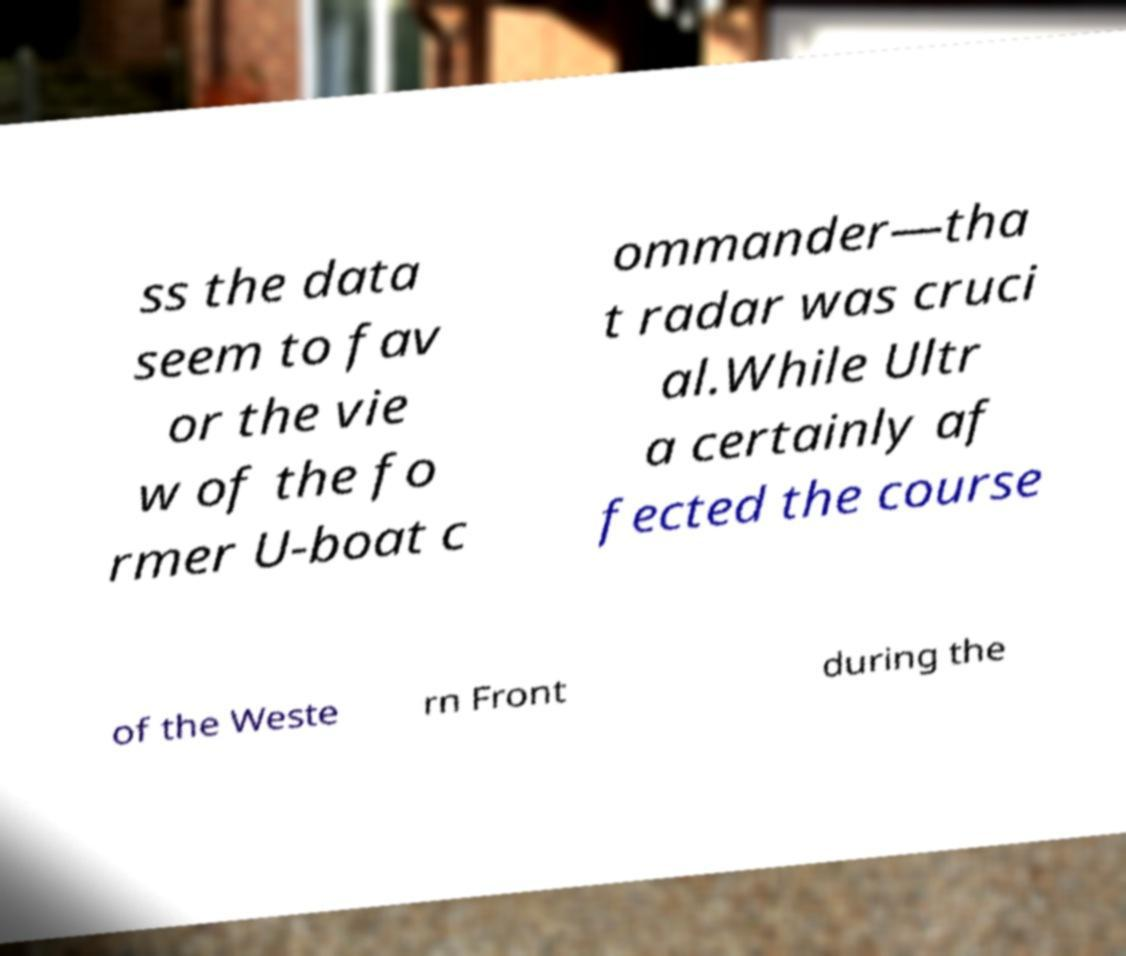Please read and relay the text visible in this image. What does it say? ss the data seem to fav or the vie w of the fo rmer U-boat c ommander—tha t radar was cruci al.While Ultr a certainly af fected the course of the Weste rn Front during the 